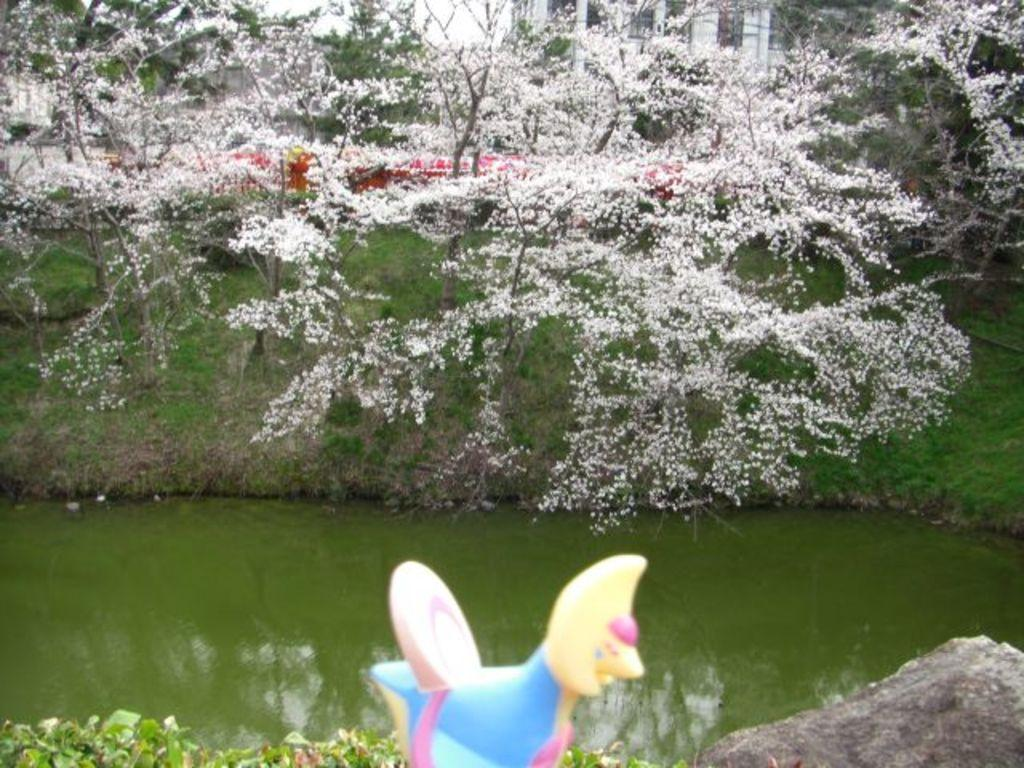What can be seen in the image? There is an object in the image. What is visible behind the object? There is water visible behind the object. What type of vegetation is present in the image? There are trees with white flowers in the image. What can be seen in the background of the image? There is a building in the background of the image. Where is the pig located in the image? There is no pig present in the image. What type of wilderness can be seen in the image? The image does not depict a wilderness setting; it features an object, water, trees with white flowers, and a building in the background. 